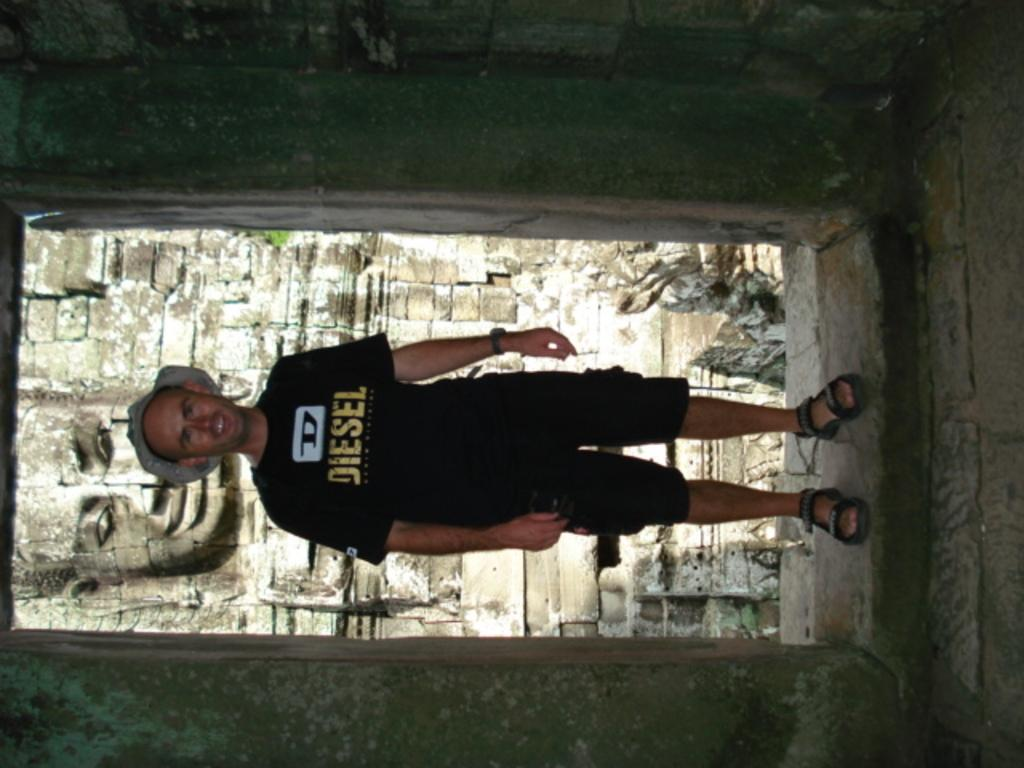What is the main subject of the image? There is a man standing in the image. What is the man wearing on his head? The man is wearing a hat. What can be seen on the wall behind the man? There is a sculptor present on the wall behind the man. How many yams are being used as a calculator in the image? There are no yams or calculators present in the image. 